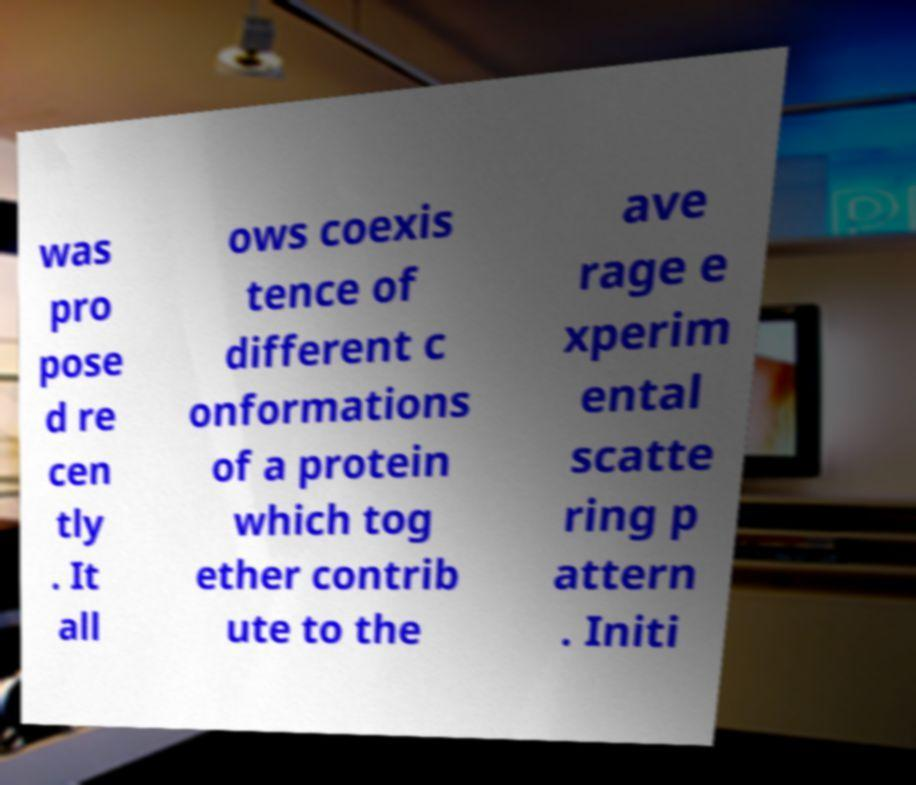Could you extract and type out the text from this image? was pro pose d re cen tly . It all ows coexis tence of different c onformations of a protein which tog ether contrib ute to the ave rage e xperim ental scatte ring p attern . Initi 